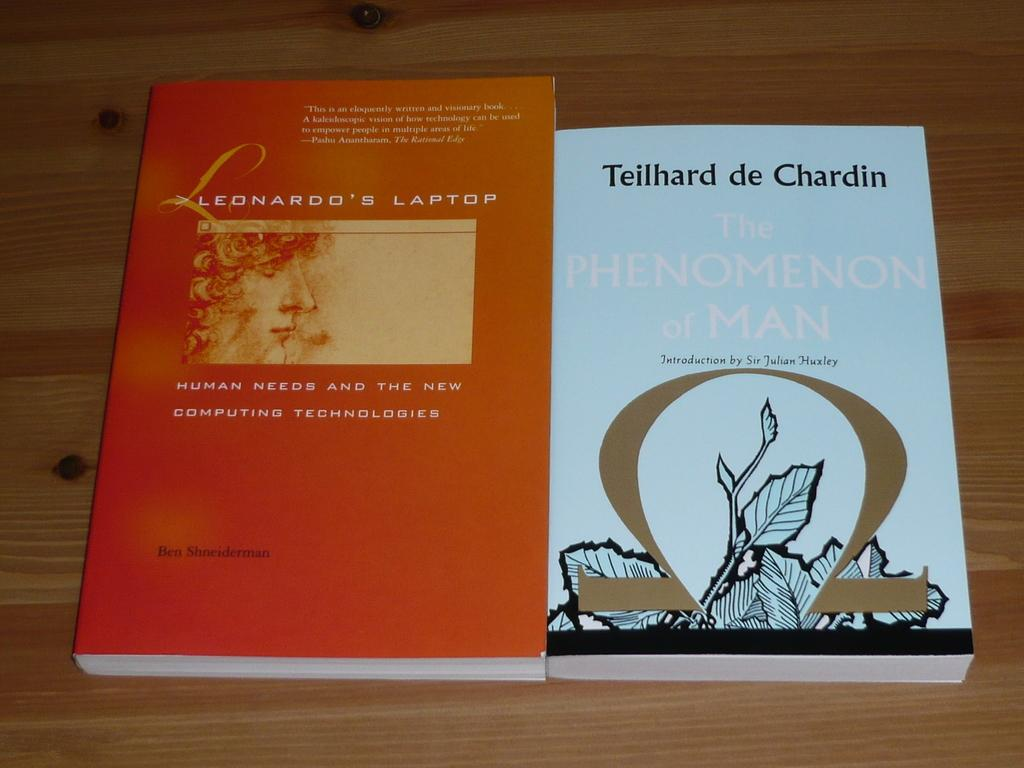<image>
Summarize the visual content of the image. Two books are on the table, Leonardo's Laptop and Teilhard de Chardin. 